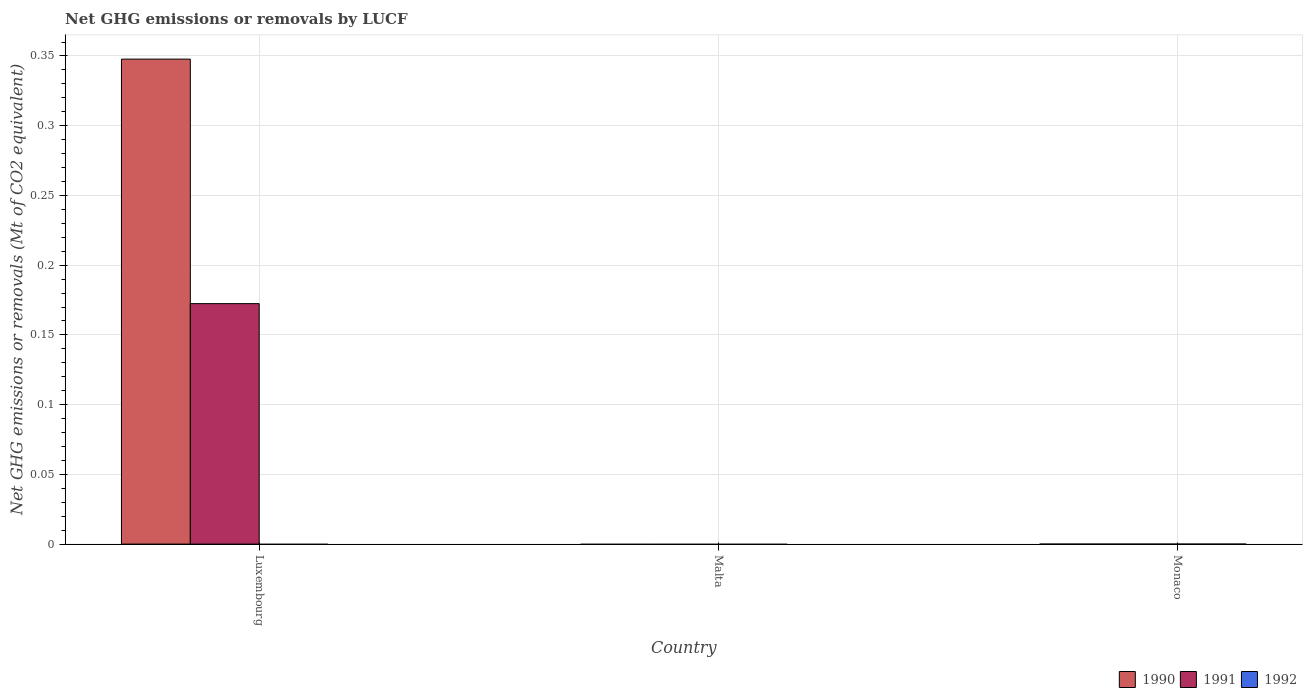How many different coloured bars are there?
Give a very brief answer. 2. Are the number of bars per tick equal to the number of legend labels?
Keep it short and to the point. No. Are the number of bars on each tick of the X-axis equal?
Ensure brevity in your answer.  No. What is the label of the 3rd group of bars from the left?
Offer a very short reply. Monaco. In how many cases, is the number of bars for a given country not equal to the number of legend labels?
Give a very brief answer. 3. What is the net GHG emissions or removals by LUCF in 1992 in Malta?
Keep it short and to the point. 0. Across all countries, what is the maximum net GHG emissions or removals by LUCF in 1990?
Ensure brevity in your answer.  0.35. In which country was the net GHG emissions or removals by LUCF in 1990 maximum?
Make the answer very short. Luxembourg. What is the difference between the net GHG emissions or removals by LUCF in 1992 in Malta and the net GHG emissions or removals by LUCF in 1990 in Luxembourg?
Your answer should be very brief. -0.35. What is the average net GHG emissions or removals by LUCF in 1990 per country?
Keep it short and to the point. 0.12. What is the difference between the net GHG emissions or removals by LUCF of/in 1990 and net GHG emissions or removals by LUCF of/in 1991 in Luxembourg?
Your answer should be very brief. 0.18. What is the difference between the highest and the lowest net GHG emissions or removals by LUCF in 1991?
Provide a succinct answer. 0.17. How many bars are there?
Offer a very short reply. 2. How many countries are there in the graph?
Provide a short and direct response. 3. What is the difference between two consecutive major ticks on the Y-axis?
Provide a short and direct response. 0.05. Are the values on the major ticks of Y-axis written in scientific E-notation?
Provide a succinct answer. No. What is the title of the graph?
Ensure brevity in your answer.  Net GHG emissions or removals by LUCF. What is the label or title of the Y-axis?
Offer a very short reply. Net GHG emissions or removals (Mt of CO2 equivalent). What is the Net GHG emissions or removals (Mt of CO2 equivalent) in 1990 in Luxembourg?
Ensure brevity in your answer.  0.35. What is the Net GHG emissions or removals (Mt of CO2 equivalent) in 1991 in Luxembourg?
Ensure brevity in your answer.  0.17. Across all countries, what is the maximum Net GHG emissions or removals (Mt of CO2 equivalent) of 1990?
Keep it short and to the point. 0.35. Across all countries, what is the maximum Net GHG emissions or removals (Mt of CO2 equivalent) in 1991?
Ensure brevity in your answer.  0.17. Across all countries, what is the minimum Net GHG emissions or removals (Mt of CO2 equivalent) in 1991?
Offer a terse response. 0. What is the total Net GHG emissions or removals (Mt of CO2 equivalent) in 1990 in the graph?
Make the answer very short. 0.35. What is the total Net GHG emissions or removals (Mt of CO2 equivalent) of 1991 in the graph?
Make the answer very short. 0.17. What is the average Net GHG emissions or removals (Mt of CO2 equivalent) in 1990 per country?
Give a very brief answer. 0.12. What is the average Net GHG emissions or removals (Mt of CO2 equivalent) in 1991 per country?
Offer a terse response. 0.06. What is the average Net GHG emissions or removals (Mt of CO2 equivalent) of 1992 per country?
Keep it short and to the point. 0. What is the difference between the Net GHG emissions or removals (Mt of CO2 equivalent) of 1990 and Net GHG emissions or removals (Mt of CO2 equivalent) of 1991 in Luxembourg?
Keep it short and to the point. 0.18. What is the difference between the highest and the lowest Net GHG emissions or removals (Mt of CO2 equivalent) of 1990?
Keep it short and to the point. 0.35. What is the difference between the highest and the lowest Net GHG emissions or removals (Mt of CO2 equivalent) in 1991?
Your response must be concise. 0.17. 